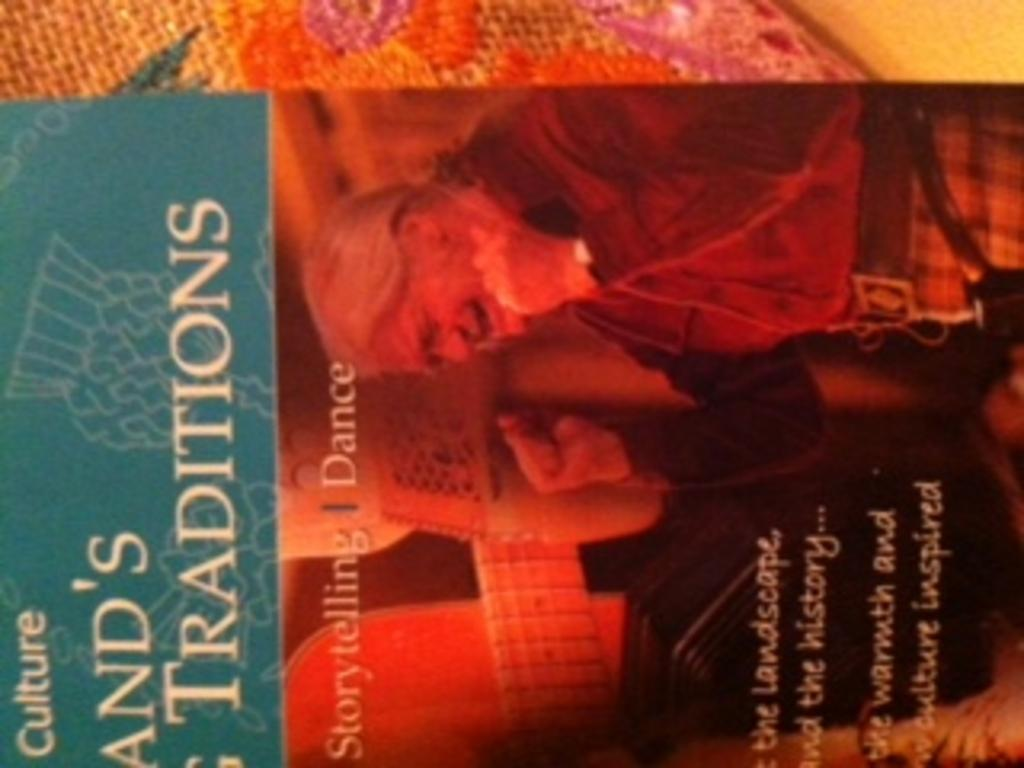<image>
Create a compact narrative representing the image presented. A book that talks about traditions of storytelling and dance 